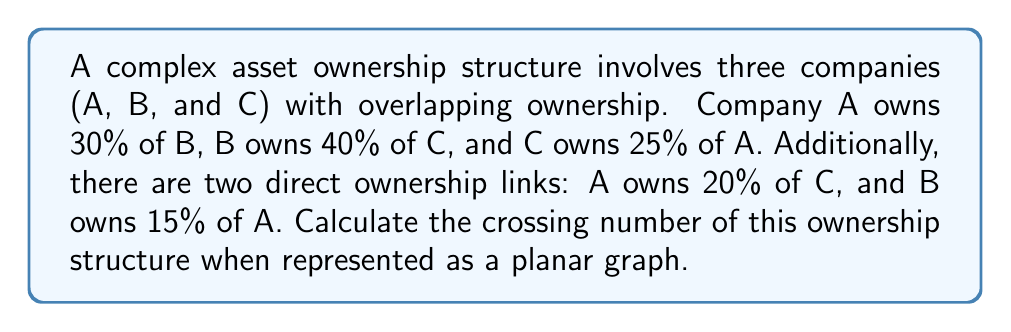Can you answer this question? To solve this problem, we need to follow these steps:

1. Represent the ownership structure as a graph:
   - Each company is a vertex (A, B, C)
   - Each ownership link is an edge

2. Draw the graph:
   [asy]
   unitsize(1cm);
   pair A = (0,2), B = (3,0), C = (0,-2);
   draw(A--B--C--A, arrow=Arrow());
   draw(A--C, arrow=Arrow());
   draw(B--A, arrow=Arrow());
   label("A", A, N);
   label("B", B, E);
   label("C", C, S);
   [/asy]

3. Count the number of crossings:
   - A→B crosses B→C
   - B→C crosses C→A
   - C→A crosses A→C
   - A→C crosses B→A

4. The crossing number is the minimum number of crossings over all possible planar embeddings of the graph. In this case, we can't eliminate any crossings without changing the graph structure.

Therefore, the crossing number is 4.
Answer: 4 